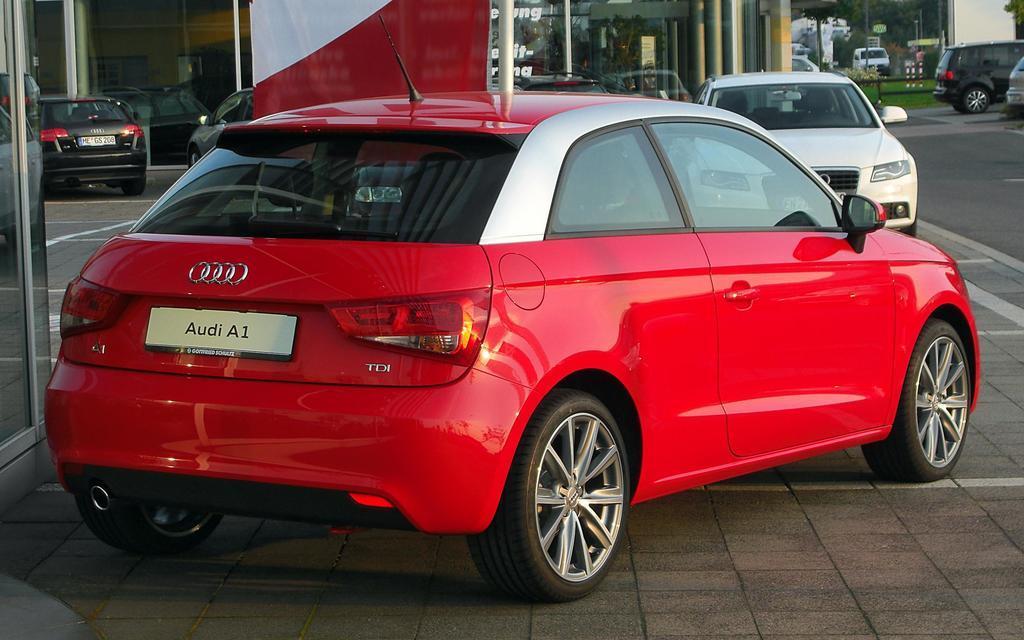Could you give a brief overview of what you see in this image? In this image there are a group of vehicles, and in the foreground there is one vehicle which is red color. At the bottom there is walkway, and in the background there are some buildings, grass and some pillars. 